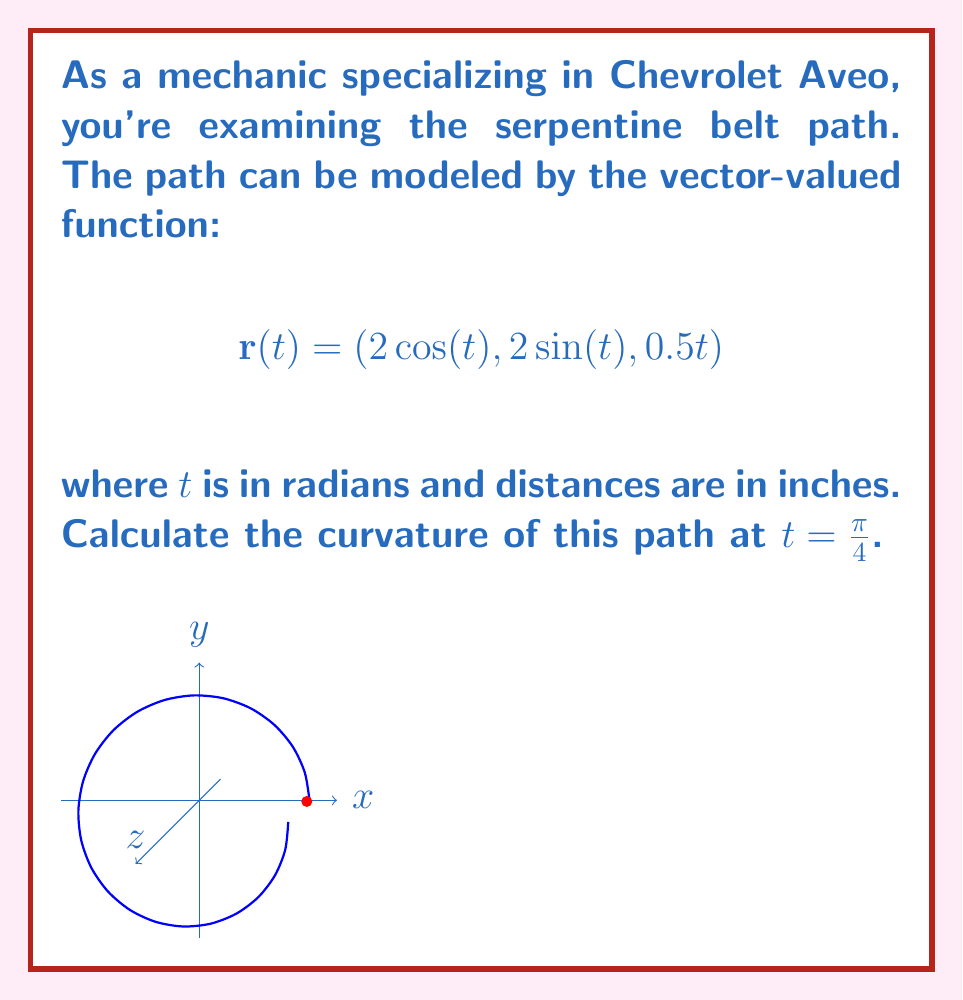Help me with this question. To find the curvature, we'll use the formula:

$$\kappa = \frac{|\mathbf{r}'(t) \times \mathbf{r}''(t)|}{|\mathbf{r}'(t)|^3}$$

Step 1: Calculate $\mathbf{r}'(t)$
$$\mathbf{r}'(t) = (-2\sin(t), 2\cos(t), 0.5)$$

Step 2: Calculate $\mathbf{r}''(t)$
$$\mathbf{r}''(t) = (-2\cos(t), -2\sin(t), 0)$$

Step 3: Evaluate $\mathbf{r}'(\frac{\pi}{4})$ and $\mathbf{r}''(\frac{\pi}{4})$
$$\mathbf{r}'(\frac{\pi}{4}) = (-\sqrt{2}, \sqrt{2}, 0.5)$$
$$\mathbf{r}''(\frac{\pi}{4}) = (-\sqrt{2}, -\sqrt{2}, 0)$$

Step 4: Calculate $\mathbf{r}'(\frac{\pi}{4}) \times \mathbf{r}''(\frac{\pi}{4})$
$$\mathbf{r}'(\frac{\pi}{4}) \times \mathbf{r}''(\frac{\pi}{4}) = (0.5\sqrt{2}, -0.5\sqrt{2}, -4)$$

Step 5: Calculate $|\mathbf{r}'(\frac{\pi}{4}) \times \mathbf{r}''(\frac{\pi}{4})|$
$$|\mathbf{r}'(\frac{\pi}{4}) \times \mathbf{r}''(\frac{\pi}{4})| = \sqrt{(0.5\sqrt{2})^2 + (-0.5\sqrt{2})^2 + (-4)^2} = \sqrt{17}$$

Step 6: Calculate $|\mathbf{r}'(\frac{\pi}{4})|$
$$|\mathbf{r}'(\frac{\pi}{4})| = \sqrt{(-\sqrt{2})^2 + (\sqrt{2})^2 + (0.5)^2} = \sqrt{4.25}$$

Step 7: Apply the curvature formula
$$\kappa = \frac{\sqrt{17}}{(\sqrt{4.25})^3} \approx 0.4564$$
Answer: $\kappa \approx 0.4564$ in$^{-1}$ 